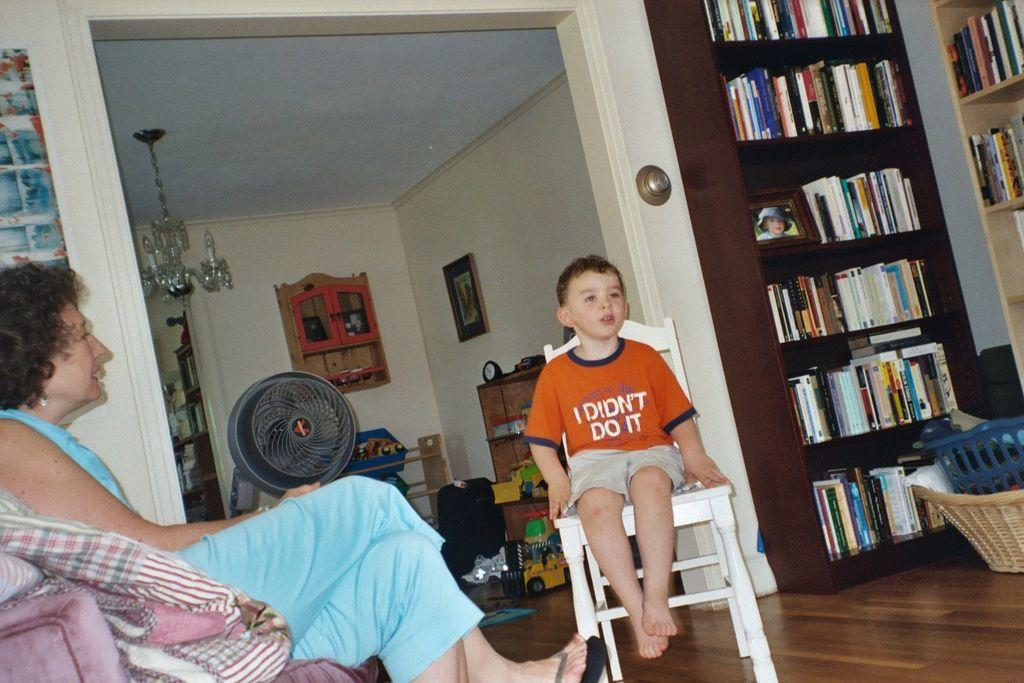<image>
Relay a brief, clear account of the picture shown. A little boy may be sitting in time out despite his shirt saying "I didn't do it". 